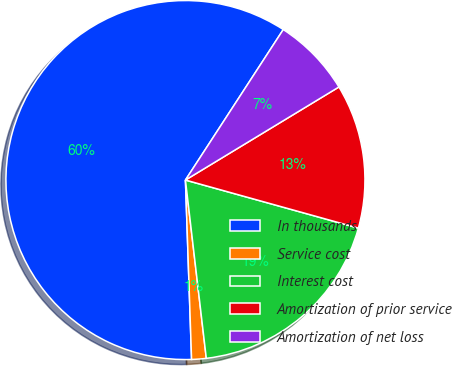<chart> <loc_0><loc_0><loc_500><loc_500><pie_chart><fcel>In thousands<fcel>Service cost<fcel>Interest cost<fcel>Amortization of prior service<fcel>Amortization of net loss<nl><fcel>59.72%<fcel>1.31%<fcel>18.83%<fcel>12.99%<fcel>7.15%<nl></chart> 